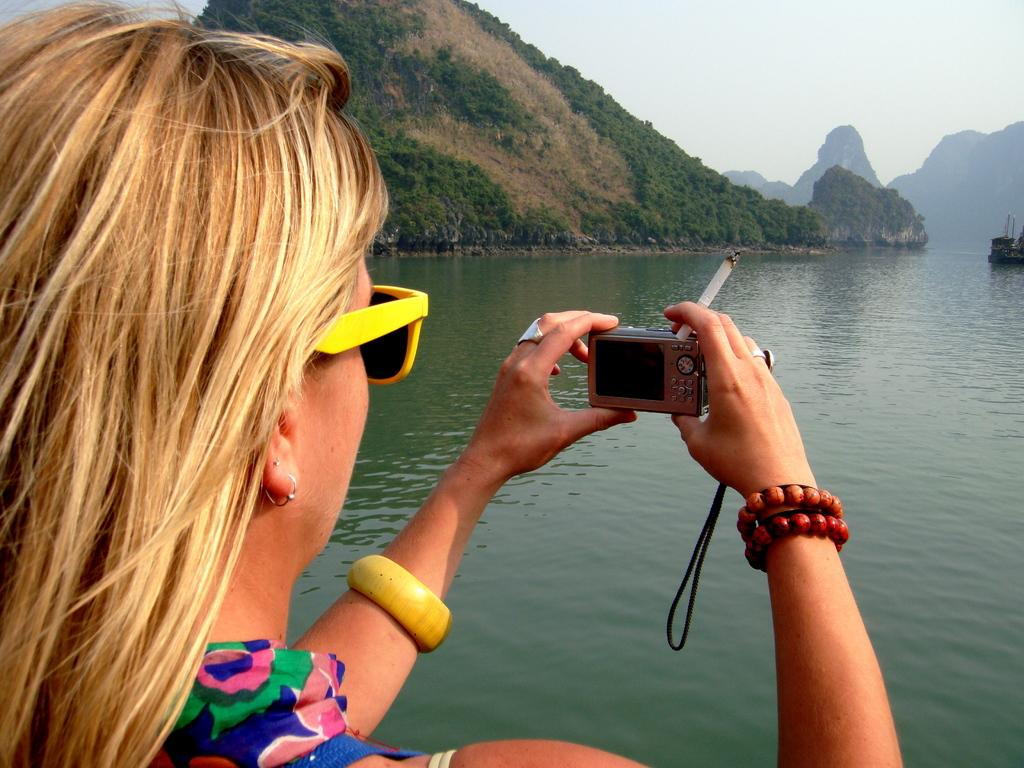Who is present in the image? There is a woman in the image. What is the woman doing in the image? The woman is standing in the image. What objects is the woman holding? The woman is holding a camera and a cigarette in the image. What can be seen in the background of the image? There is a river in front of the woman in the image. How many kittens are playing with the wren near the river in the image? There are no kittens or wrens present in the image. 